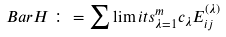<formula> <loc_0><loc_0><loc_500><loc_500>\ B a r { H \, } \colon = \sum \lim i t s _ { \lambda = 1 } ^ { m } c _ { \lambda } E _ { i j } ^ { ( \lambda ) }</formula> 